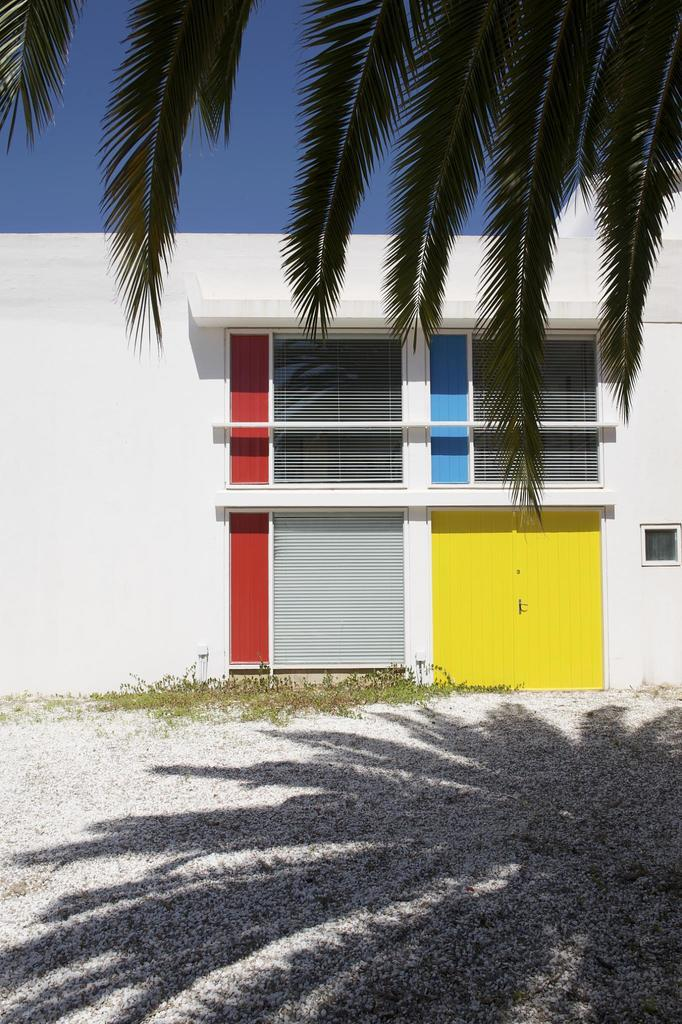What type of structure is present in the image? There is a building in the image. What natural element is also visible in the image? There is a tree in the image. What can be seen in the distance behind the building and tree? The sky is visible in the background of the image. How do the ants contribute to the rhythm of the care in the image? There are no ants present in the image, so it is not possible to determine their contribution to the rhythm of the care. 